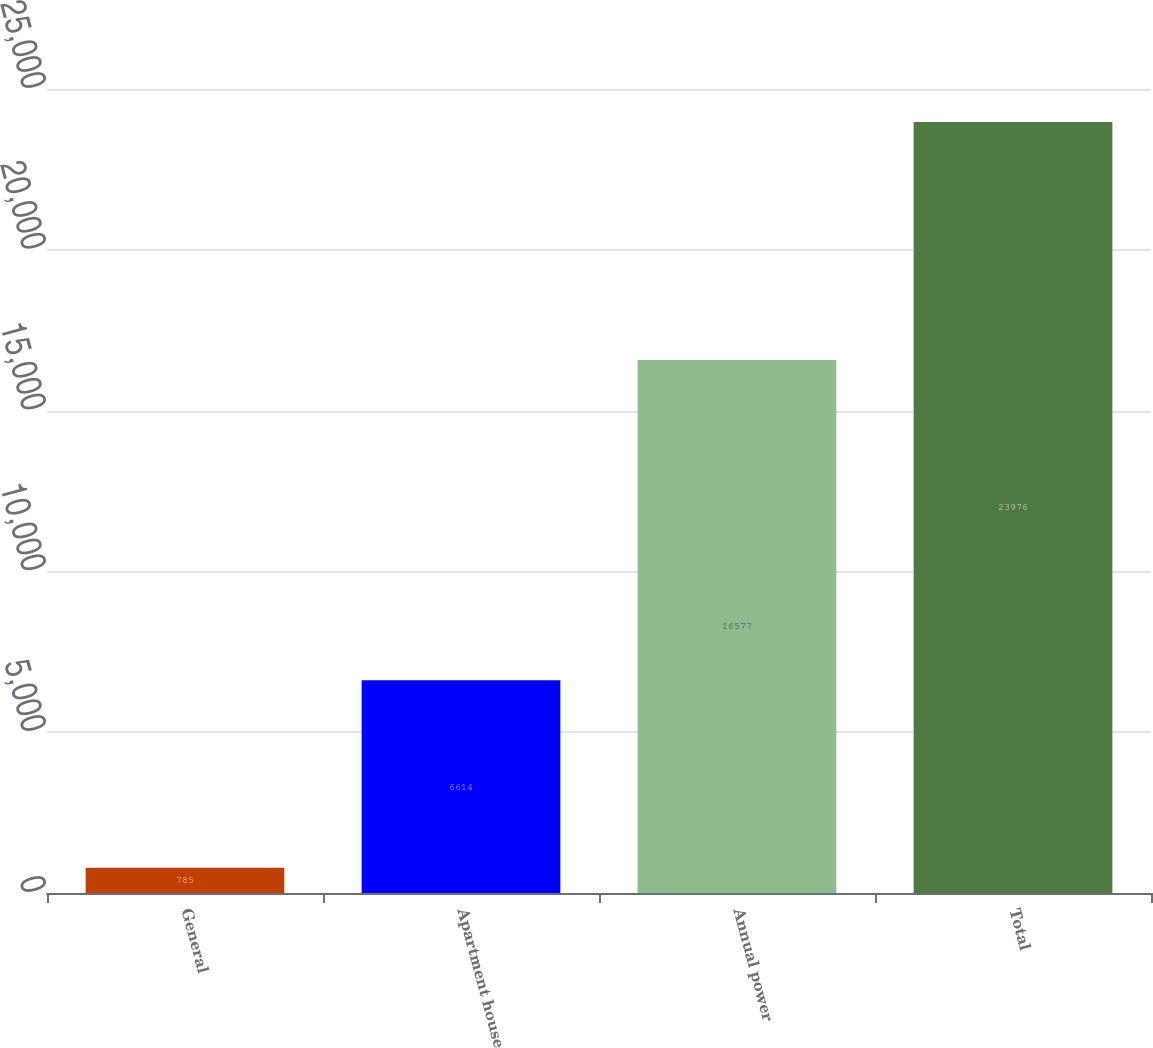<chart> <loc_0><loc_0><loc_500><loc_500><bar_chart><fcel>General<fcel>Apartment house<fcel>Annual power<fcel>Total<nl><fcel>785<fcel>6614<fcel>16577<fcel>23976<nl></chart> 